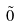Convert formula to latex. <formula><loc_0><loc_0><loc_500><loc_500>\tilde { 0 }</formula> 